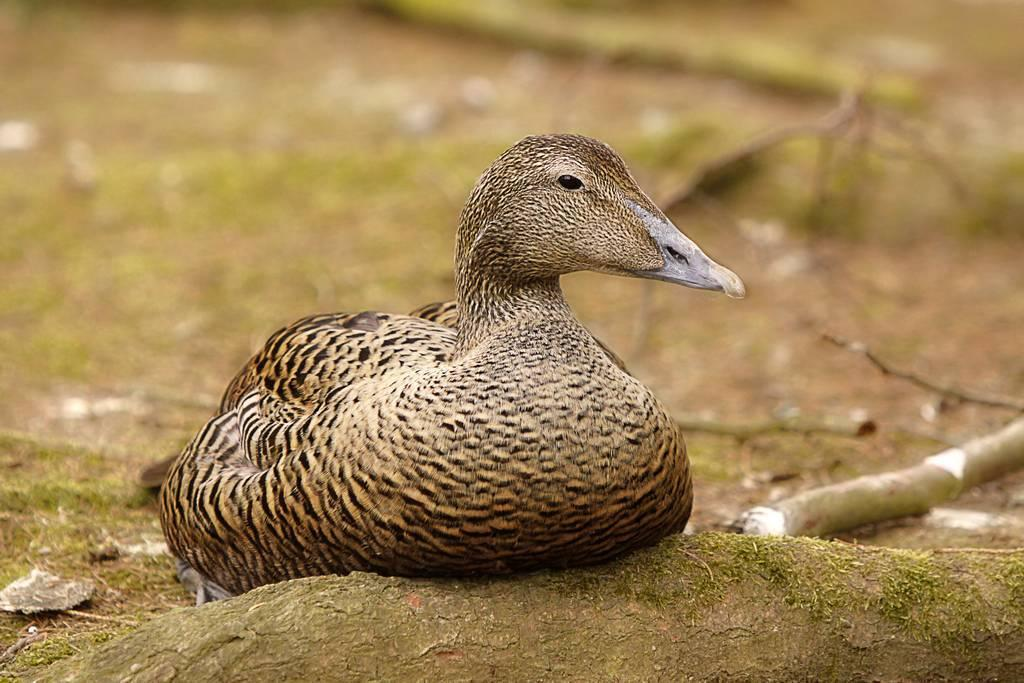What type of animal can be seen in the image? There is a bird in the image. What object is present in the image alongside the bird? There is a wooden log in the image. Can you describe the background of the image? The background of the image is slightly blurred. What type of expert is giving a lecture in the image? There is no expert or lecture present in the image; it features a bird and a wooden log with a slightly blurred background. 